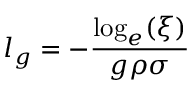<formula> <loc_0><loc_0><loc_500><loc_500>l _ { g } = - \frac { \log _ { e } ( \xi ) } { g \rho \sigma }</formula> 